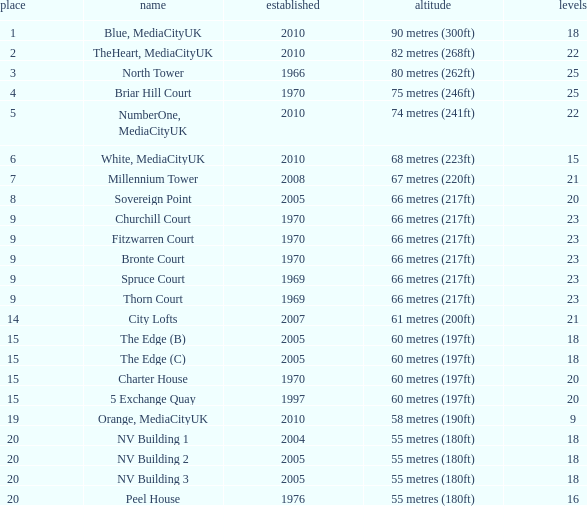What is the lowest Built, when Floors is greater than 23, and when Rank is 3? 1966.0. 